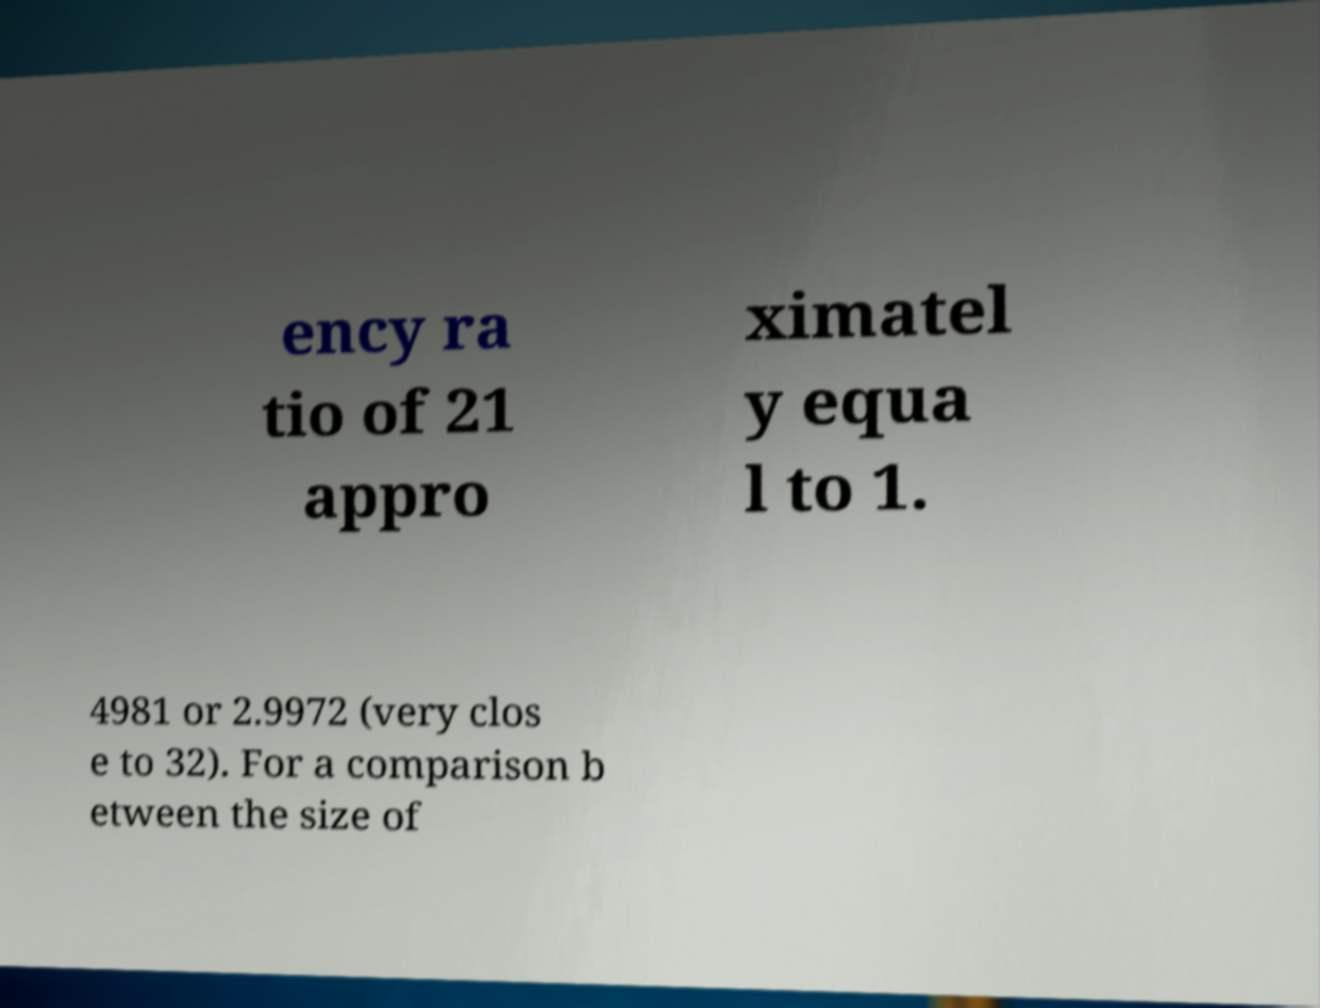For documentation purposes, I need the text within this image transcribed. Could you provide that? ency ra tio of 21 appro ximatel y equa l to 1. 4981 or 2.9972 (very clos e to 32). For a comparison b etween the size of 